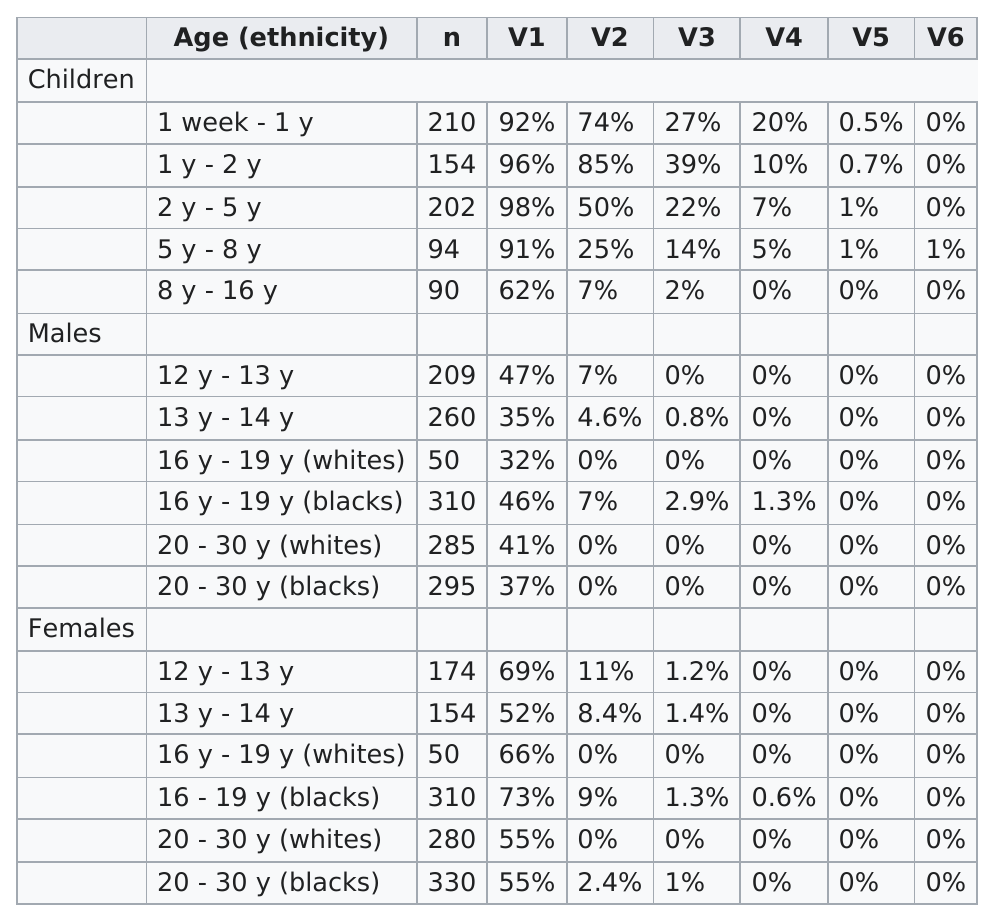Point out several critical features in this image. What is the recommended dose of v5 for children under the age of one? 0.5%... The first age in which T-waves were measured was one week. 